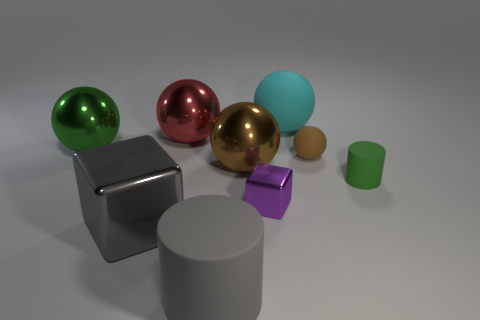Subtract all cyan spheres. How many spheres are left? 4 Subtract all cyan balls. How many balls are left? 4 Subtract all yellow balls. Subtract all gray cylinders. How many balls are left? 5 Add 1 big red metal cylinders. How many objects exist? 10 Subtract all cylinders. How many objects are left? 7 Add 5 green cylinders. How many green cylinders are left? 6 Add 5 small spheres. How many small spheres exist? 6 Subtract 0 red cubes. How many objects are left? 9 Subtract all yellow metallic things. Subtract all big cyan matte things. How many objects are left? 8 